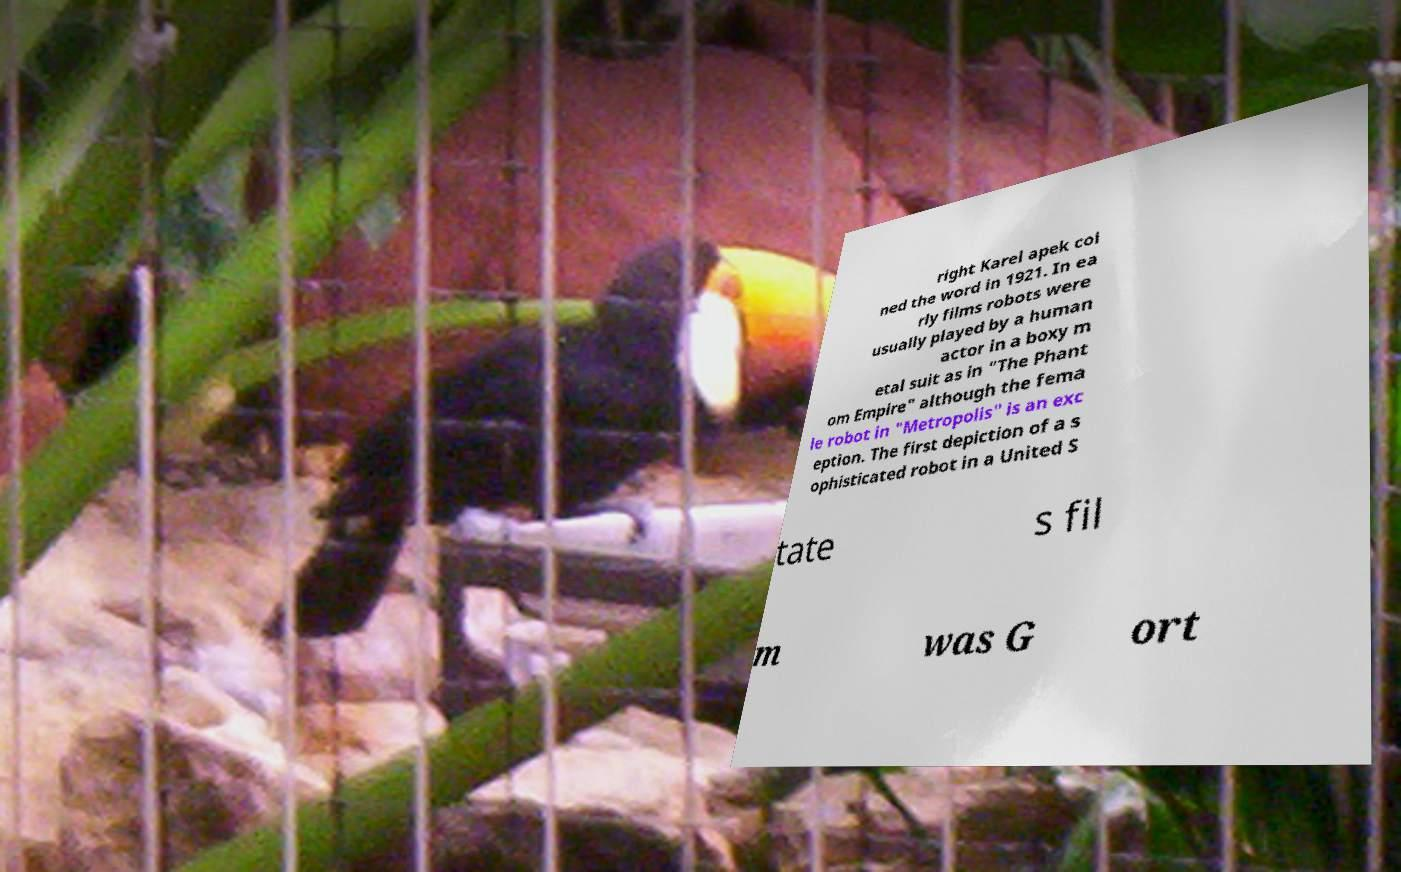Please read and relay the text visible in this image. What does it say? right Karel apek coi ned the word in 1921. In ea rly films robots were usually played by a human actor in a boxy m etal suit as in "The Phant om Empire" although the fema le robot in "Metropolis" is an exc eption. The first depiction of a s ophisticated robot in a United S tate s fil m was G ort 